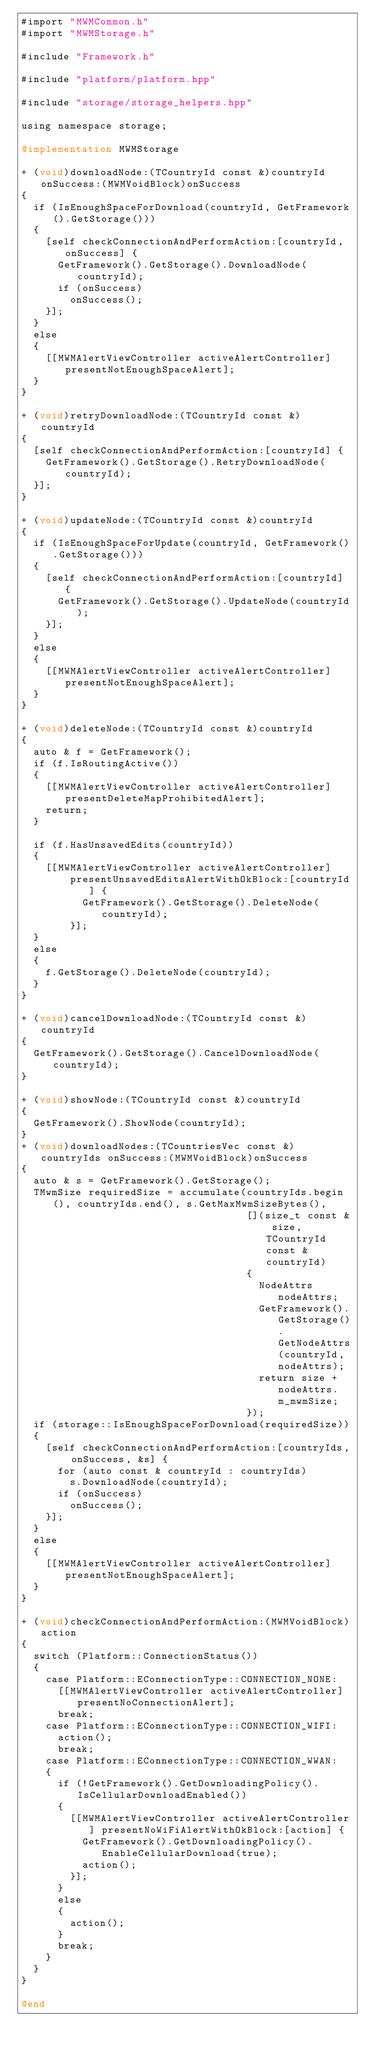<code> <loc_0><loc_0><loc_500><loc_500><_ObjectiveC_>#import "MWMCommon.h"
#import "MWMStorage.h"

#include "Framework.h"

#include "platform/platform.hpp"

#include "storage/storage_helpers.hpp"

using namespace storage;

@implementation MWMStorage

+ (void)downloadNode:(TCountryId const &)countryId onSuccess:(MWMVoidBlock)onSuccess
{
  if (IsEnoughSpaceForDownload(countryId, GetFramework().GetStorage()))
  {
    [self checkConnectionAndPerformAction:[countryId, onSuccess] {
      GetFramework().GetStorage().DownloadNode(countryId);
      if (onSuccess)
        onSuccess();
    }];
  }
  else
  {
    [[MWMAlertViewController activeAlertController] presentNotEnoughSpaceAlert];
  }
}

+ (void)retryDownloadNode:(TCountryId const &)countryId
{
  [self checkConnectionAndPerformAction:[countryId] {
    GetFramework().GetStorage().RetryDownloadNode(countryId);
  }];
}

+ (void)updateNode:(TCountryId const &)countryId
{
  if (IsEnoughSpaceForUpdate(countryId, GetFramework().GetStorage()))
  {
    [self checkConnectionAndPerformAction:[countryId] {
      GetFramework().GetStorage().UpdateNode(countryId);
    }];
  }
  else
  {
    [[MWMAlertViewController activeAlertController] presentNotEnoughSpaceAlert];
  }
}

+ (void)deleteNode:(TCountryId const &)countryId
{
  auto & f = GetFramework();
  if (f.IsRoutingActive())
  {
    [[MWMAlertViewController activeAlertController] presentDeleteMapProhibitedAlert];
    return;
  }

  if (f.HasUnsavedEdits(countryId))
  {
    [[MWMAlertViewController activeAlertController]
        presentUnsavedEditsAlertWithOkBlock:[countryId] {
          GetFramework().GetStorage().DeleteNode(countryId);
        }];
  }
  else
  {
    f.GetStorage().DeleteNode(countryId);
  }
}

+ (void)cancelDownloadNode:(TCountryId const &)countryId
{
  GetFramework().GetStorage().CancelDownloadNode(countryId);
}

+ (void)showNode:(TCountryId const &)countryId
{
  GetFramework().ShowNode(countryId);
}
+ (void)downloadNodes:(TCountriesVec const &)countryIds onSuccess:(MWMVoidBlock)onSuccess
{
  auto & s = GetFramework().GetStorage();
  TMwmSize requiredSize = accumulate(countryIds.begin(), countryIds.end(), s.GetMaxMwmSizeBytes(),
                                     [](size_t const & size, TCountryId const & countryId)
                                     {
                                       NodeAttrs nodeAttrs;
                                       GetFramework().GetStorage().GetNodeAttrs(countryId, nodeAttrs);
                                       return size + nodeAttrs.m_mwmSize;
                                     });
  if (storage::IsEnoughSpaceForDownload(requiredSize))
  {
    [self checkConnectionAndPerformAction:[countryIds, onSuccess, &s] {
      for (auto const & countryId : countryIds)
        s.DownloadNode(countryId);
      if (onSuccess)
        onSuccess();
    }];
  }
  else
  {
    [[MWMAlertViewController activeAlertController] presentNotEnoughSpaceAlert];
  }
}

+ (void)checkConnectionAndPerformAction:(MWMVoidBlock)action
{
  switch (Platform::ConnectionStatus())
  {
    case Platform::EConnectionType::CONNECTION_NONE:
      [[MWMAlertViewController activeAlertController] presentNoConnectionAlert];
      break;
    case Platform::EConnectionType::CONNECTION_WIFI:
      action();
      break;
    case Platform::EConnectionType::CONNECTION_WWAN:
    {
      if (!GetFramework().GetDownloadingPolicy().IsCellularDownloadEnabled())
      {
        [[MWMAlertViewController activeAlertController] presentNoWiFiAlertWithOkBlock:[action] {
          GetFramework().GetDownloadingPolicy().EnableCellularDownload(true);
          action();
        }];
      }
      else
      {
        action();
      }
      break;
    }
  }
}

@end
</code> 